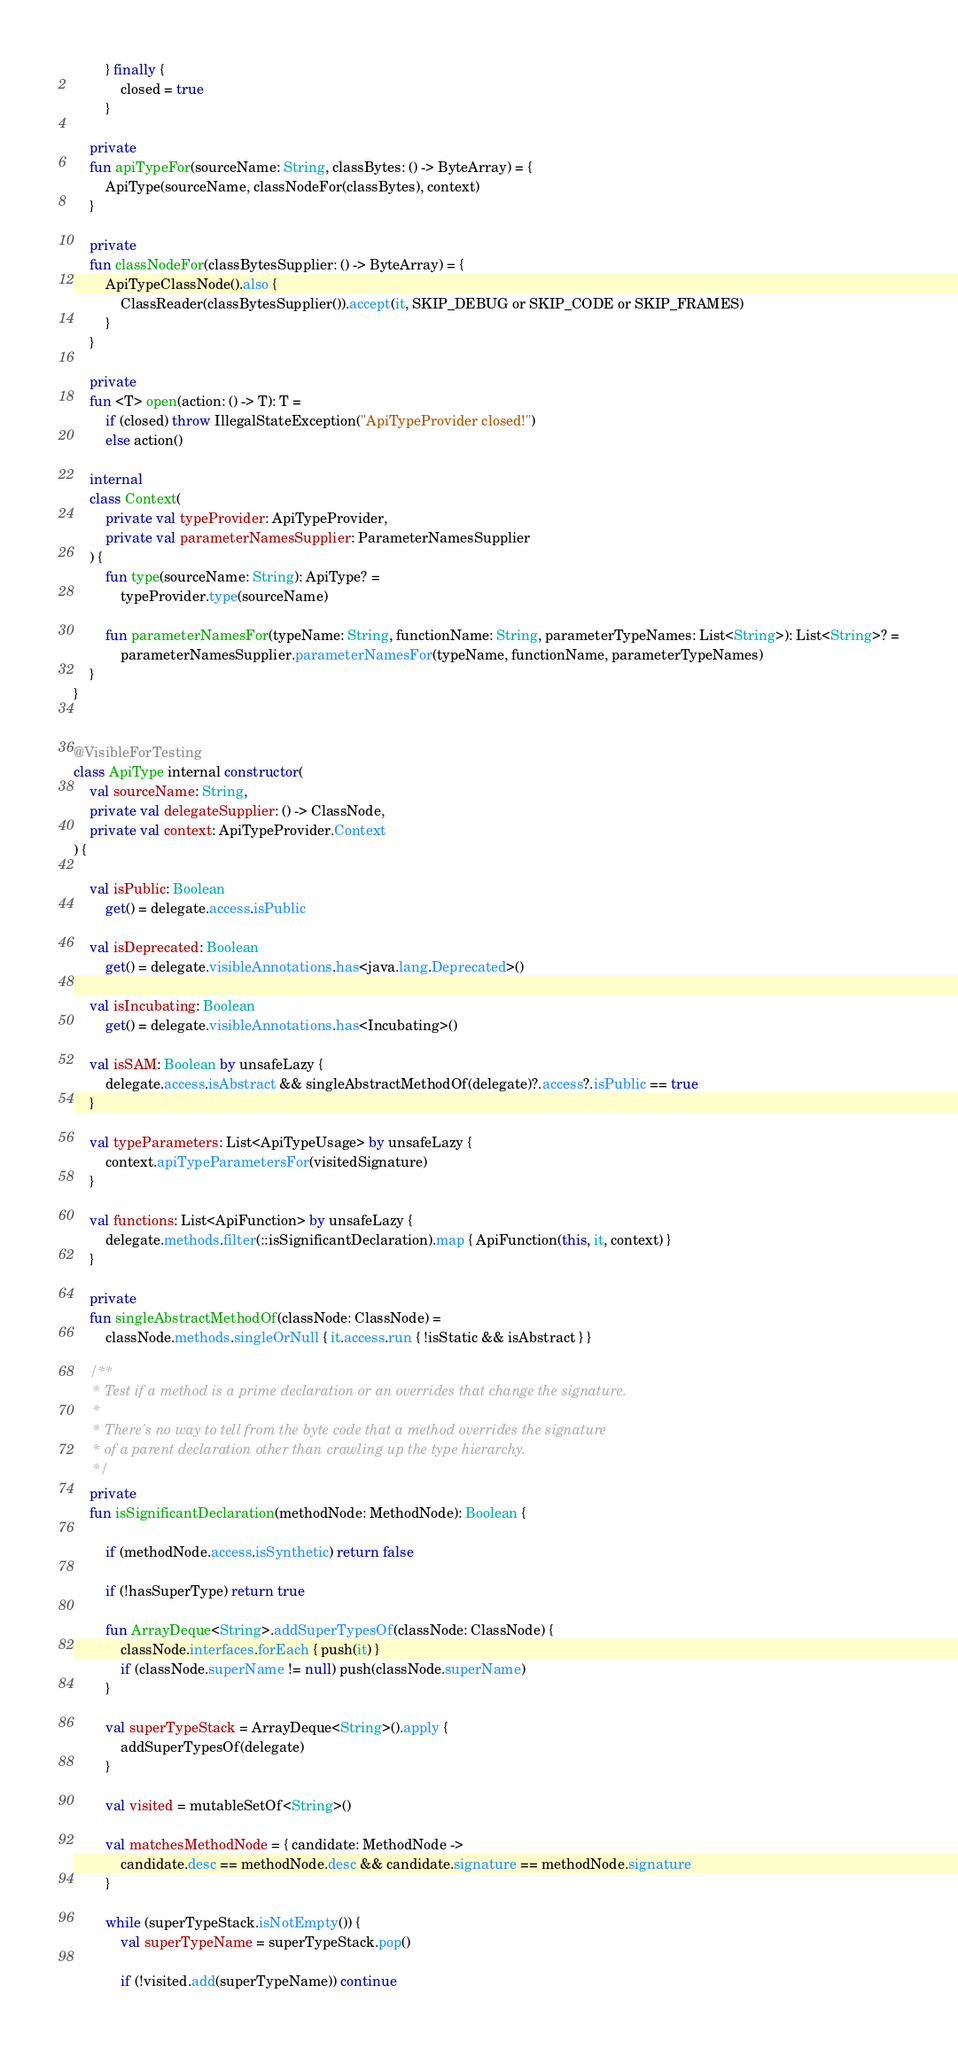<code> <loc_0><loc_0><loc_500><loc_500><_Kotlin_>        } finally {
            closed = true
        }

    private
    fun apiTypeFor(sourceName: String, classBytes: () -> ByteArray) = {
        ApiType(sourceName, classNodeFor(classBytes), context)
    }

    private
    fun classNodeFor(classBytesSupplier: () -> ByteArray) = {
        ApiTypeClassNode().also {
            ClassReader(classBytesSupplier()).accept(it, SKIP_DEBUG or SKIP_CODE or SKIP_FRAMES)
        }
    }

    private
    fun <T> open(action: () -> T): T =
        if (closed) throw IllegalStateException("ApiTypeProvider closed!")
        else action()

    internal
    class Context(
        private val typeProvider: ApiTypeProvider,
        private val parameterNamesSupplier: ParameterNamesSupplier
    ) {
        fun type(sourceName: String): ApiType? =
            typeProvider.type(sourceName)

        fun parameterNamesFor(typeName: String, functionName: String, parameterTypeNames: List<String>): List<String>? =
            parameterNamesSupplier.parameterNamesFor(typeName, functionName, parameterTypeNames)
    }
}


@VisibleForTesting
class ApiType internal constructor(
    val sourceName: String,
    private val delegateSupplier: () -> ClassNode,
    private val context: ApiTypeProvider.Context
) {

    val isPublic: Boolean
        get() = delegate.access.isPublic

    val isDeprecated: Boolean
        get() = delegate.visibleAnnotations.has<java.lang.Deprecated>()

    val isIncubating: Boolean
        get() = delegate.visibleAnnotations.has<Incubating>()

    val isSAM: Boolean by unsafeLazy {
        delegate.access.isAbstract && singleAbstractMethodOf(delegate)?.access?.isPublic == true
    }

    val typeParameters: List<ApiTypeUsage> by unsafeLazy {
        context.apiTypeParametersFor(visitedSignature)
    }

    val functions: List<ApiFunction> by unsafeLazy {
        delegate.methods.filter(::isSignificantDeclaration).map { ApiFunction(this, it, context) }
    }

    private
    fun singleAbstractMethodOf(classNode: ClassNode) =
        classNode.methods.singleOrNull { it.access.run { !isStatic && isAbstract } }

    /**
     * Test if a method is a prime declaration or an overrides that change the signature.
     *
     * There's no way to tell from the byte code that a method overrides the signature
     * of a parent declaration other than crawling up the type hierarchy.
     */
    private
    fun isSignificantDeclaration(methodNode: MethodNode): Boolean {

        if (methodNode.access.isSynthetic) return false

        if (!hasSuperType) return true

        fun ArrayDeque<String>.addSuperTypesOf(classNode: ClassNode) {
            classNode.interfaces.forEach { push(it) }
            if (classNode.superName != null) push(classNode.superName)
        }

        val superTypeStack = ArrayDeque<String>().apply {
            addSuperTypesOf(delegate)
        }

        val visited = mutableSetOf<String>()

        val matchesMethodNode = { candidate: MethodNode ->
            candidate.desc == methodNode.desc && candidate.signature == methodNode.signature
        }

        while (superTypeStack.isNotEmpty()) {
            val superTypeName = superTypeStack.pop()

            if (!visited.add(superTypeName)) continue
</code> 